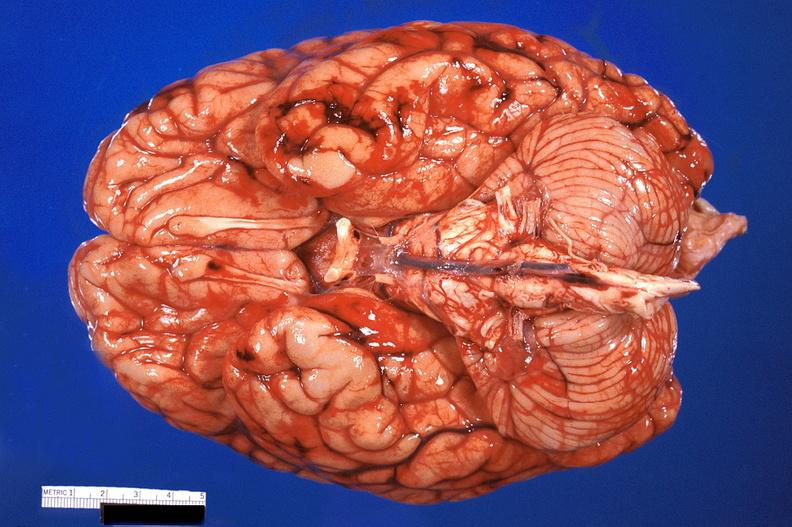what does this image show?
Answer the question using a single word or phrase. Brain 